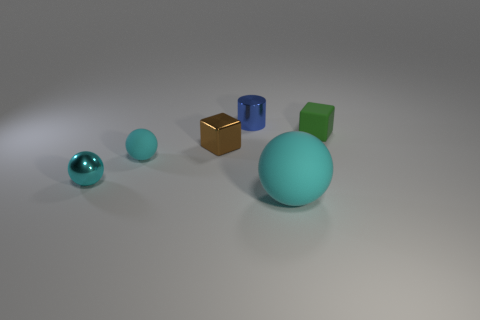How many metallic objects are either blue things or tiny cyan things?
Provide a succinct answer. 2. What number of tiny objects are both left of the tiny brown metal cube and behind the metal sphere?
Offer a terse response. 1. Is there any other thing that has the same shape as the small cyan shiny thing?
Provide a succinct answer. Yes. How many other things are there of the same size as the brown object?
Ensure brevity in your answer.  4. Do the rubber object that is right of the big cyan thing and the metal thing that is right of the brown metal object have the same size?
Make the answer very short. Yes. How many objects are either green blocks or rubber things that are on the left side of the brown metallic object?
Ensure brevity in your answer.  2. There is a brown thing left of the matte block; what is its size?
Offer a terse response. Small. Are there fewer tiny green rubber blocks behind the tiny blue object than tiny cylinders on the right side of the small green rubber object?
Your response must be concise. No. There is a sphere that is on the right side of the cyan shiny sphere and left of the tiny blue metallic cylinder; what material is it?
Offer a very short reply. Rubber. What shape is the cyan object on the right side of the metal thing that is behind the small green matte cube?
Your answer should be compact. Sphere. 